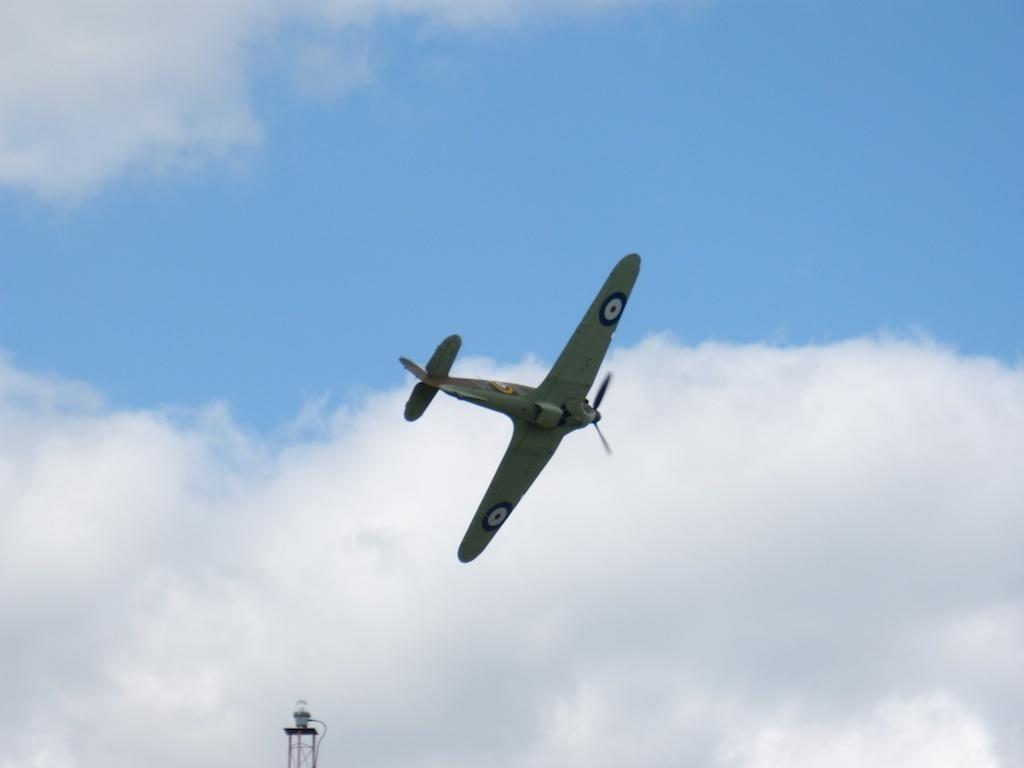What is the main subject of the image? The main subject of the image is an aeroplane. What is the aeroplane doing in the image? The aeroplane is flying in the sky. What structure can be seen at the bottom of the image? There is a tower at the bottom of the image. What type of juice is being served in the aeroplane? There is no juice or any indication of a serving in the image; it only shows an aeroplane flying in the sky and a tower at the bottom. 